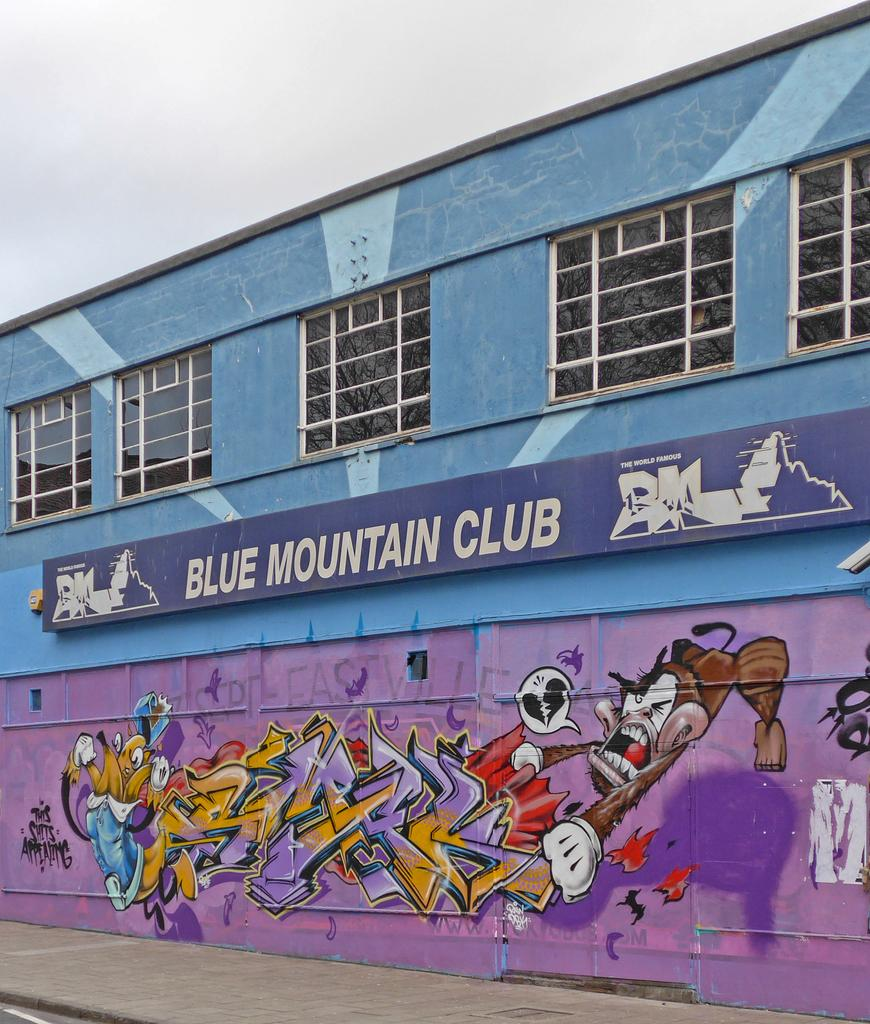<image>
Write a terse but informative summary of the picture. the side of a building with graffiti and the name blue mountain club in white 